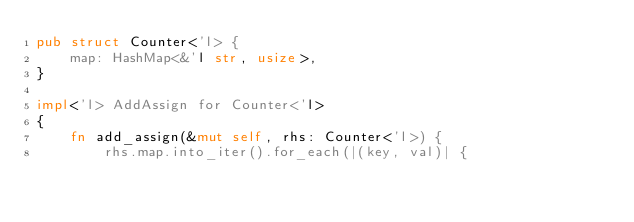Convert code to text. <code><loc_0><loc_0><loc_500><loc_500><_Rust_>pub struct Counter<'l> {
    map: HashMap<&'l str, usize>,
}

impl<'l> AddAssign for Counter<'l>
{
    fn add_assign(&mut self, rhs: Counter<'l>) {
        rhs.map.into_iter().for_each(|(key, val)| {</code> 